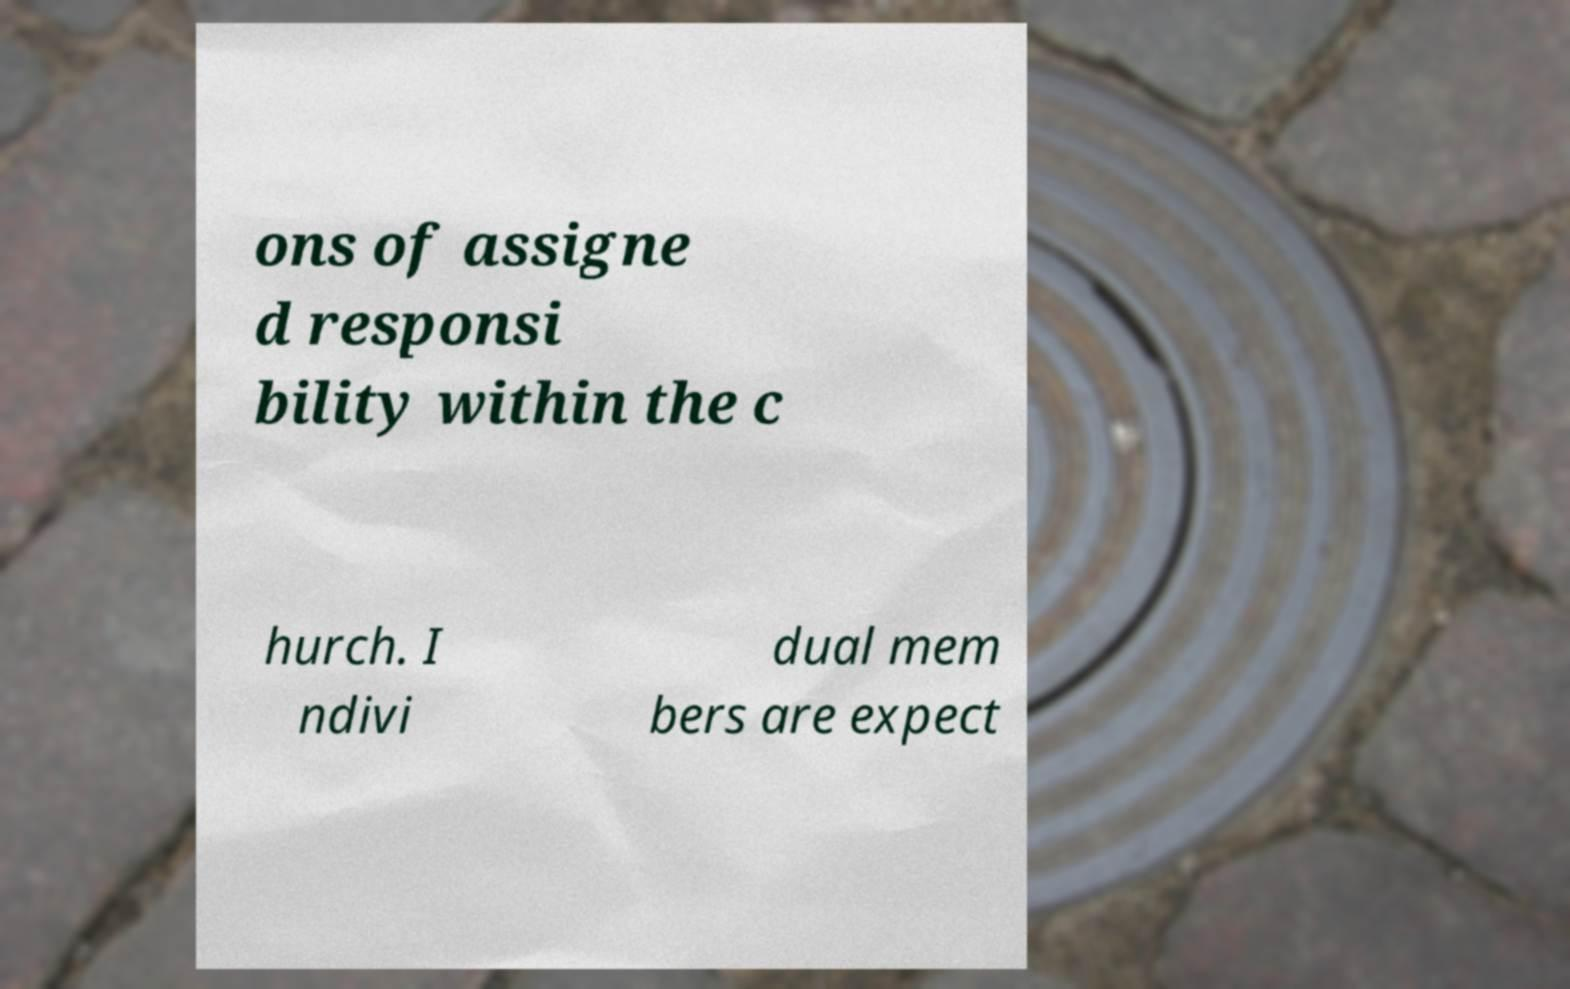What messages or text are displayed in this image? I need them in a readable, typed format. ons of assigne d responsi bility within the c hurch. I ndivi dual mem bers are expect 